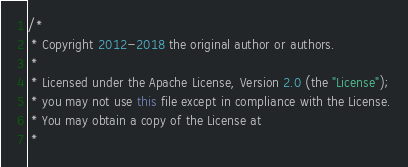Convert code to text. <code><loc_0><loc_0><loc_500><loc_500><_Java_>/*
 * Copyright 2012-2018 the original author or authors.
 *
 * Licensed under the Apache License, Version 2.0 (the "License");
 * you may not use this file except in compliance with the License.
 * You may obtain a copy of the License at
 *</code> 